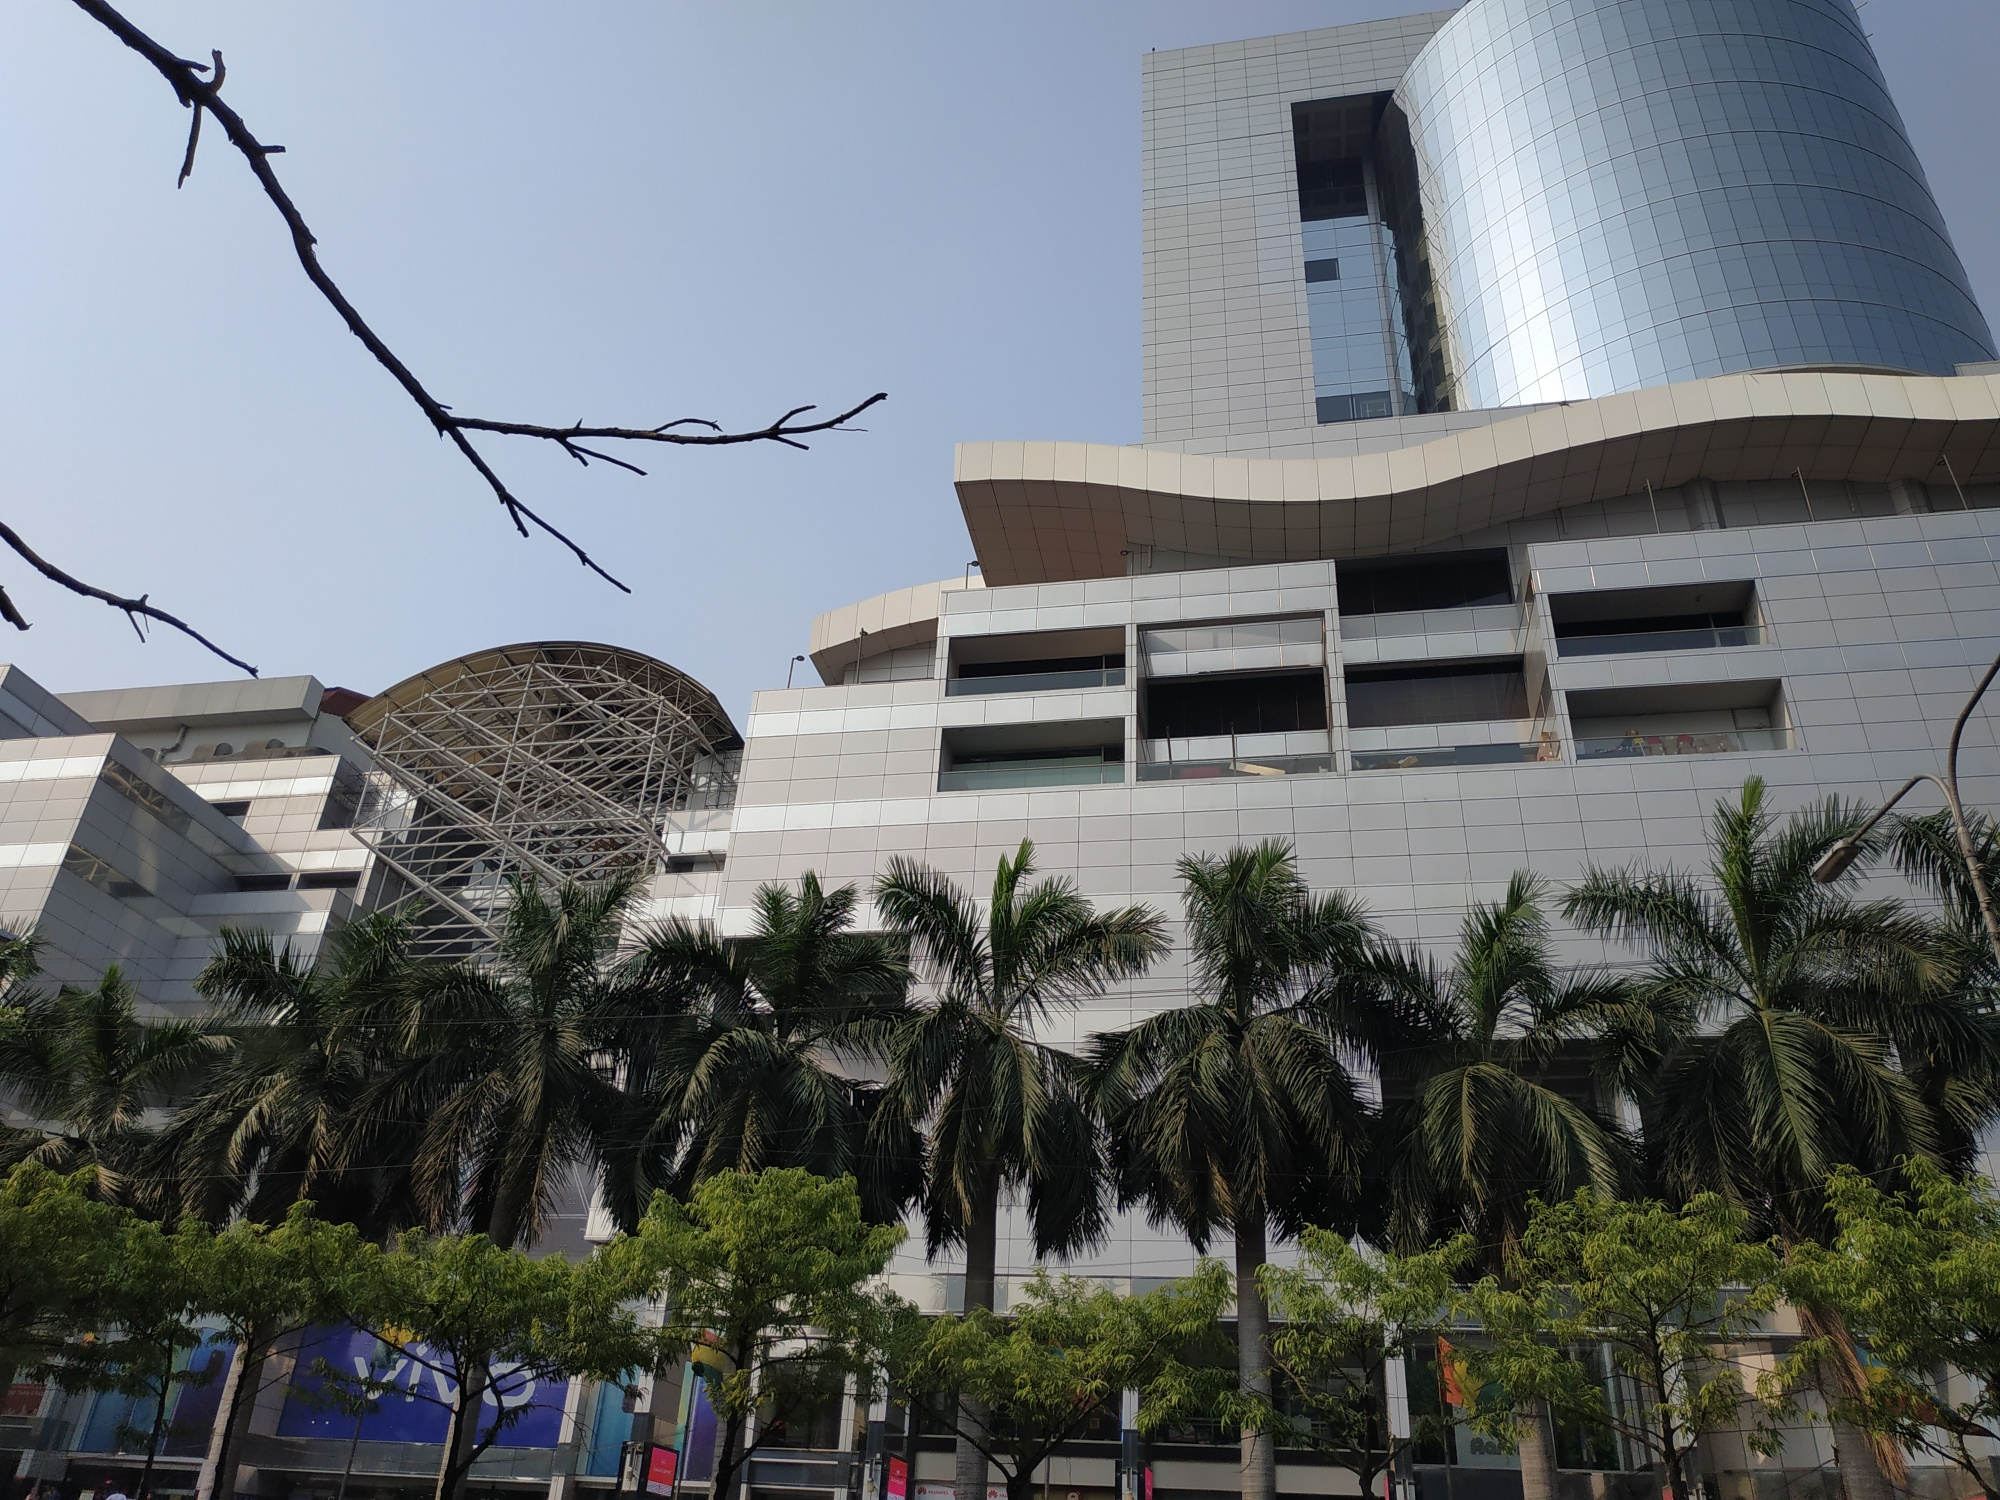Imagine this building was designed for a post-apocalyptic world. How would it function and look? In a post-apocalyptic world, this building would stand as a fortress of hope and resilience. The sleek, reflective glass would be replaced with reinforced materials capable of withstanding harsh environmental conditions. The metal dome could serve as a barrier against radiation or toxic atmospheres, with air filtration systems incorporated into the infrastructure. Solar panels might cover the exterior, providing a self-sustaining energy source. The once transparent facade would be embedded with advanced defense mechanisms to protect its inhabitants from external threats. Inside, the building functions as a self-contained ecosystem, with hydroponic gardens producing food and water purification systems ensuring a clean supply. It’s a stronghold of innovation and survival, a sanctuary for the remnants of humanity seeking solace and safety amidst the ruins of the old world. 